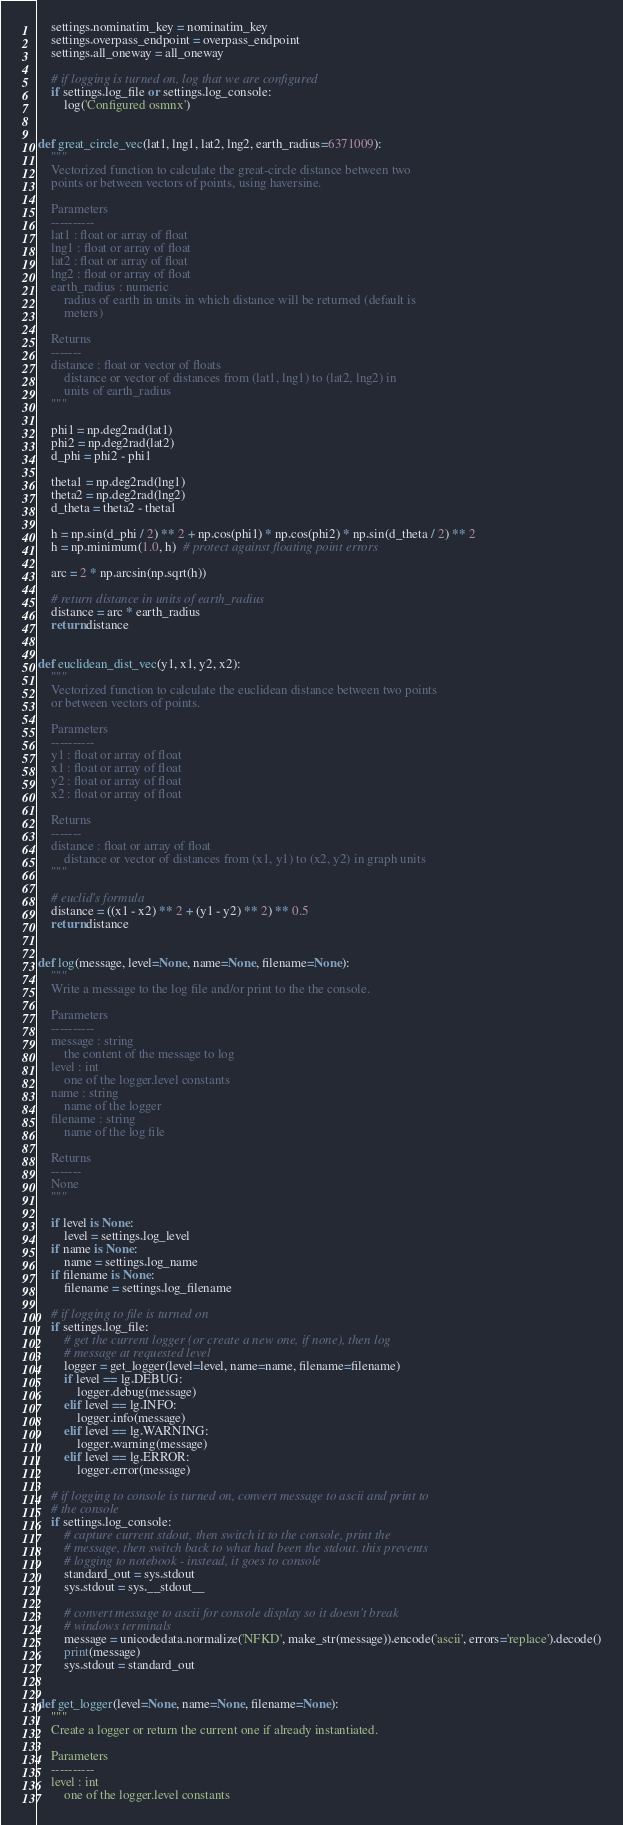Convert code to text. <code><loc_0><loc_0><loc_500><loc_500><_Python_>    settings.nominatim_key = nominatim_key
    settings.overpass_endpoint = overpass_endpoint
    settings.all_oneway = all_oneway

    # if logging is turned on, log that we are configured
    if settings.log_file or settings.log_console:
        log('Configured osmnx')


def great_circle_vec(lat1, lng1, lat2, lng2, earth_radius=6371009):
    """
    Vectorized function to calculate the great-circle distance between two
    points or between vectors of points, using haversine.

    Parameters
    ----------
    lat1 : float or array of float
    lng1 : float or array of float
    lat2 : float or array of float
    lng2 : float or array of float
    earth_radius : numeric
        radius of earth in units in which distance will be returned (default is
        meters)

    Returns
    -------
    distance : float or vector of floats
        distance or vector of distances from (lat1, lng1) to (lat2, lng2) in
        units of earth_radius
    """

    phi1 = np.deg2rad(lat1)
    phi2 = np.deg2rad(lat2)
    d_phi = phi2 - phi1

    theta1 = np.deg2rad(lng1)
    theta2 = np.deg2rad(lng2)
    d_theta = theta2 - theta1

    h = np.sin(d_phi / 2) ** 2 + np.cos(phi1) * np.cos(phi2) * np.sin(d_theta / 2) ** 2
    h = np.minimum(1.0, h)  # protect against floating point errors

    arc = 2 * np.arcsin(np.sqrt(h))

    # return distance in units of earth_radius
    distance = arc * earth_radius
    return distance


def euclidean_dist_vec(y1, x1, y2, x2):
    """
    Vectorized function to calculate the euclidean distance between two points
    or between vectors of points.

    Parameters
    ----------
    y1 : float or array of float
    x1 : float or array of float
    y2 : float or array of float
    x2 : float or array of float

    Returns
    -------
    distance : float or array of float
        distance or vector of distances from (x1, y1) to (x2, y2) in graph units
    """

    # euclid's formula
    distance = ((x1 - x2) ** 2 + (y1 - y2) ** 2) ** 0.5
    return distance


def log(message, level=None, name=None, filename=None):
    """
    Write a message to the log file and/or print to the the console.

    Parameters
    ----------
    message : string
        the content of the message to log
    level : int
        one of the logger.level constants
    name : string
        name of the logger
    filename : string
        name of the log file

    Returns
    -------
    None
    """

    if level is None:
        level = settings.log_level
    if name is None:
        name = settings.log_name
    if filename is None:
        filename = settings.log_filename

    # if logging to file is turned on
    if settings.log_file:
        # get the current logger (or create a new one, if none), then log
        # message at requested level
        logger = get_logger(level=level, name=name, filename=filename)
        if level == lg.DEBUG:
            logger.debug(message)
        elif level == lg.INFO:
            logger.info(message)
        elif level == lg.WARNING:
            logger.warning(message)
        elif level == lg.ERROR:
            logger.error(message)

    # if logging to console is turned on, convert message to ascii and print to
    # the console
    if settings.log_console:
        # capture current stdout, then switch it to the console, print the
        # message, then switch back to what had been the stdout. this prevents
        # logging to notebook - instead, it goes to console
        standard_out = sys.stdout
        sys.stdout = sys.__stdout__

        # convert message to ascii for console display so it doesn't break
        # windows terminals
        message = unicodedata.normalize('NFKD', make_str(message)).encode('ascii', errors='replace').decode()
        print(message)
        sys.stdout = standard_out


def get_logger(level=None, name=None, filename=None):
    """
    Create a logger or return the current one if already instantiated.

    Parameters
    ----------
    level : int
        one of the logger.level constants</code> 